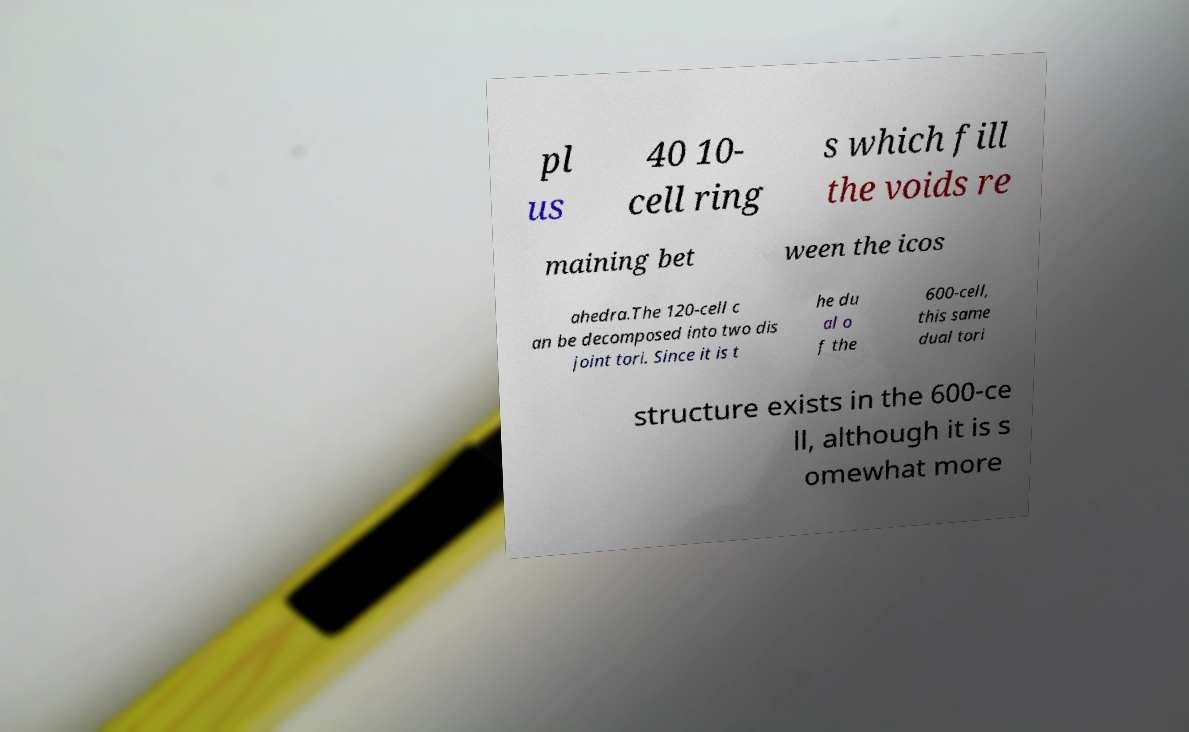Can you accurately transcribe the text from the provided image for me? pl us 40 10- cell ring s which fill the voids re maining bet ween the icos ahedra.The 120-cell c an be decomposed into two dis joint tori. Since it is t he du al o f the 600-cell, this same dual tori structure exists in the 600-ce ll, although it is s omewhat more 